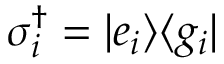Convert formula to latex. <formula><loc_0><loc_0><loc_500><loc_500>\sigma _ { i } ^ { \dagger } = | e _ { i } \rangle \langle g _ { i } |</formula> 